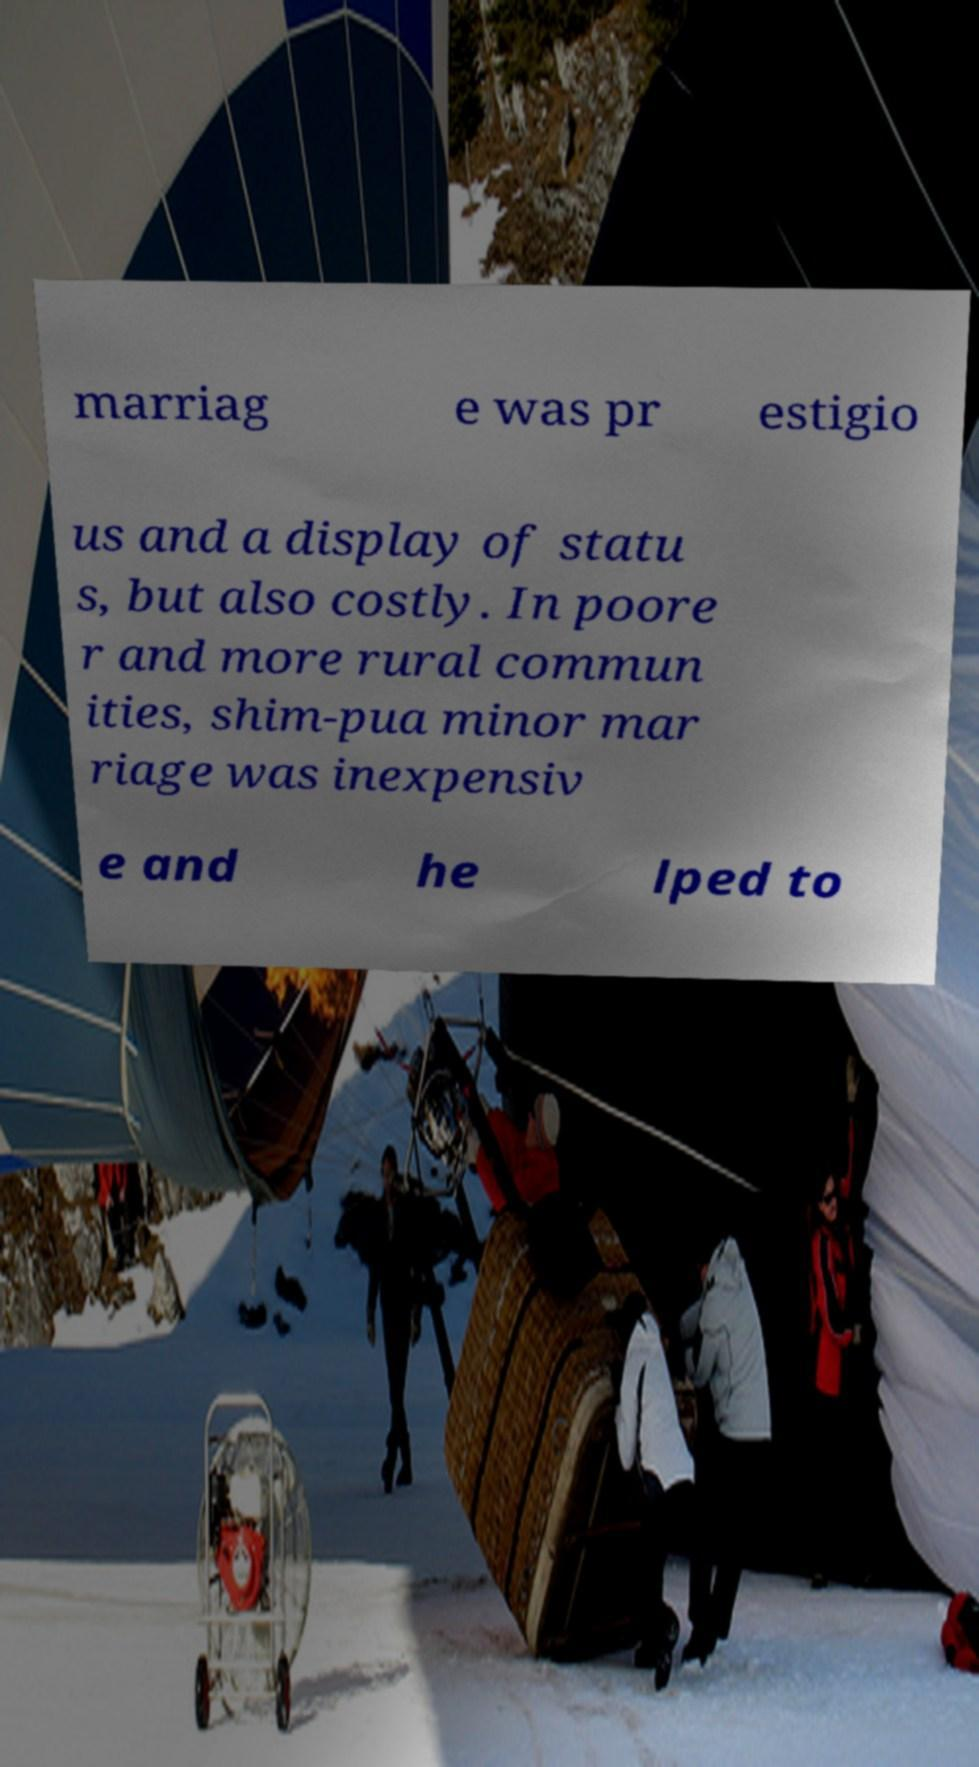What messages or text are displayed in this image? I need them in a readable, typed format. marriag e was pr estigio us and a display of statu s, but also costly. In poore r and more rural commun ities, shim-pua minor mar riage was inexpensiv e and he lped to 